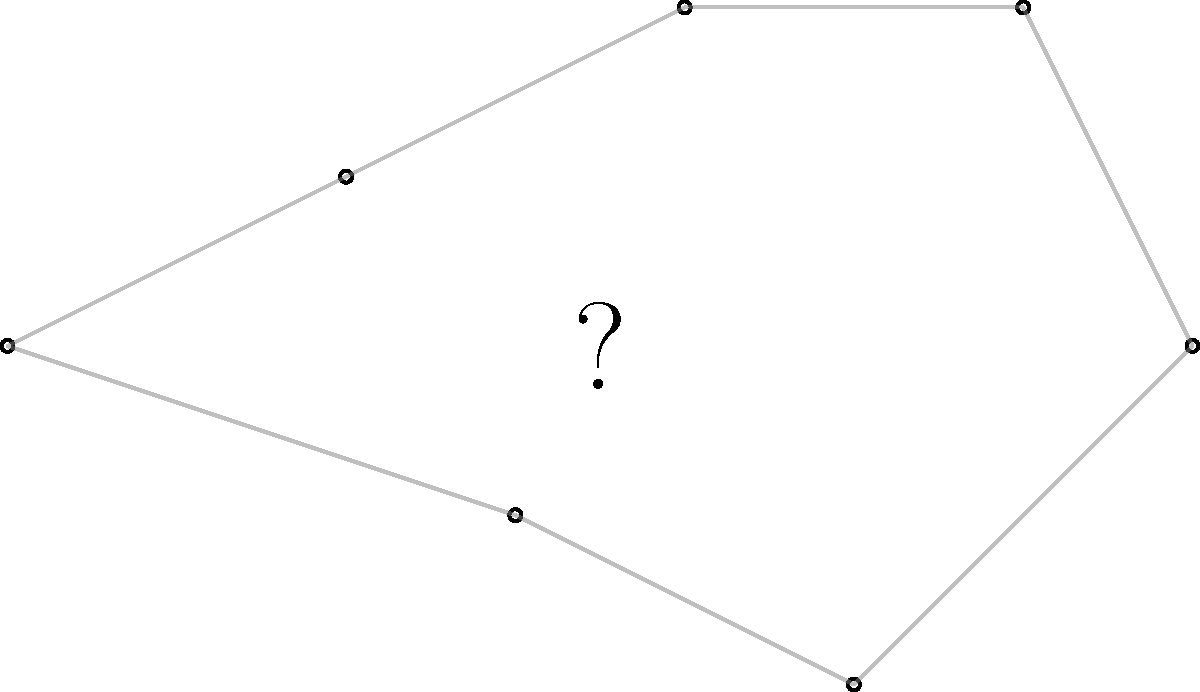As a technology provider offering complementary products for astronomy software, you're developing a constellation identification feature. Which well-known constellation is represented by the star pattern shown in the image? To identify this constellation, let's follow these steps:

1. Observe the overall shape: The pattern forms a distinct "ladle" or "dipper" shape.
2. Count the stars: There are 7 prominent stars in the pattern.
3. Analyze the configuration:
   - Four stars form a quadrilateral shape (the "bowl" of the dipper).
   - Three stars extend from one corner, forming a curved "handle."
4. Recognize the pattern: This is one of the most recognizable patterns in the night sky.
5. Identify the constellation: This pattern is known as the "Big Dipper" or "The Plough."
6. Correlate with official constellations: The Big Dipper is actually an asterism (a prominent pattern of stars) within a larger constellation.
7. Determine the full constellation: The Big Dipper is part of the constellation Ursa Major, also known as the Great Bear.

In astronomy software, this pattern would be a key feature for users to locate and identify, as it's often used as a starting point for finding other constellations and celestial objects.
Answer: Ursa Major 